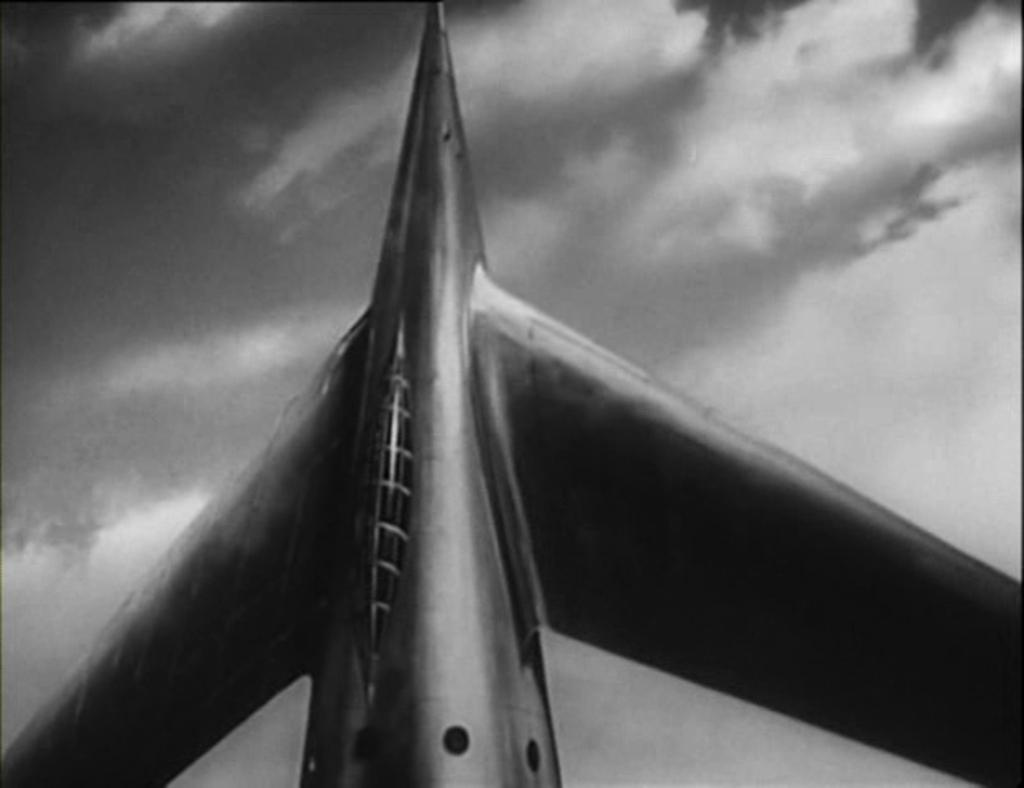What is the main subject of the image? The main subject of the image is a rocket. What can be seen in the background of the image? There are clouds visible in the background of the image. What type of wilderness can be seen in the image? There is no wilderness present in the image; it features a rocket and clouds. How many robins can be seen flying around the rocket in the image? There are no robins present in the image. 